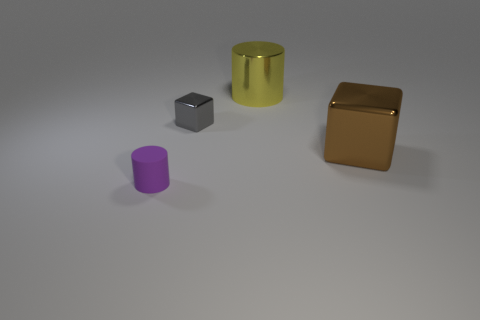Add 1 small rubber cylinders. How many objects exist? 5 Add 4 big gray metal balls. How many big gray metal balls exist? 4 Subtract 0 red cylinders. How many objects are left? 4 Subtract all blue rubber balls. Subtract all gray shiny blocks. How many objects are left? 3 Add 1 tiny blocks. How many tiny blocks are left? 2 